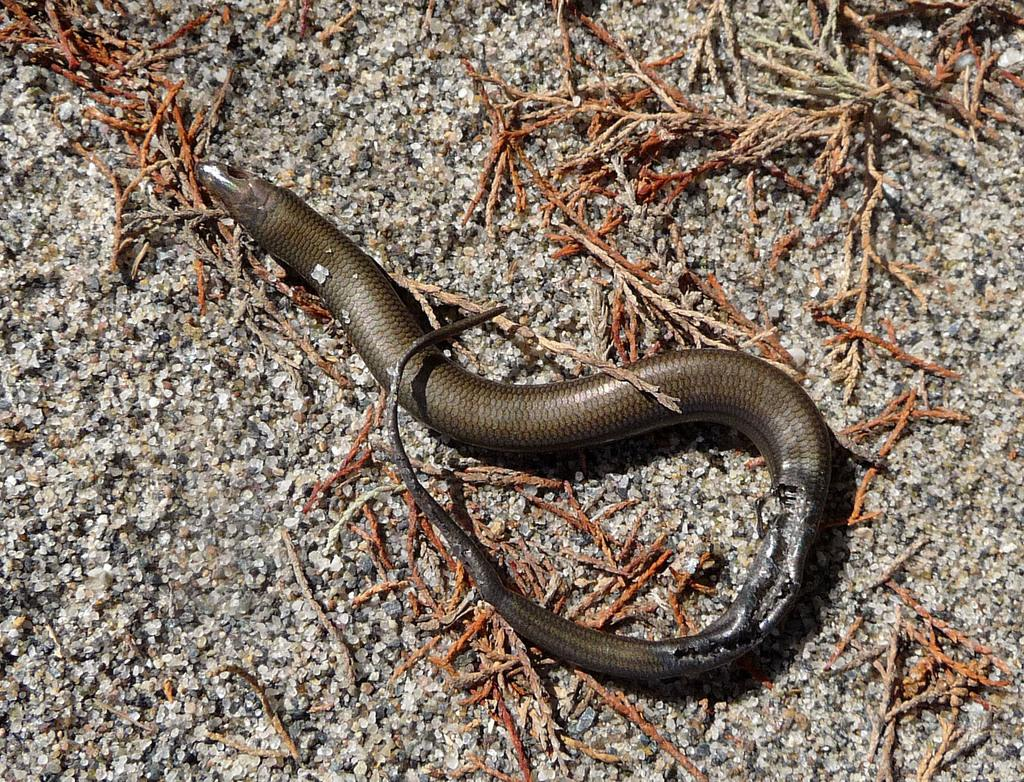What type of animal is in the image? There is a snake in the image. What is the terrain like in the image? There is sand and dry grass in the image. Can you describe the environment in the image? The environment in the image consists of sand and dry grass, which suggests a desert-like setting. Where is the faucet located in the image? There is no faucet present in the image. How does the snake contribute to the distribution of resources in the image? The snake does not contribute to the distribution of resources in the image, as it is an individual animal and not a part of a larger ecosystem. 